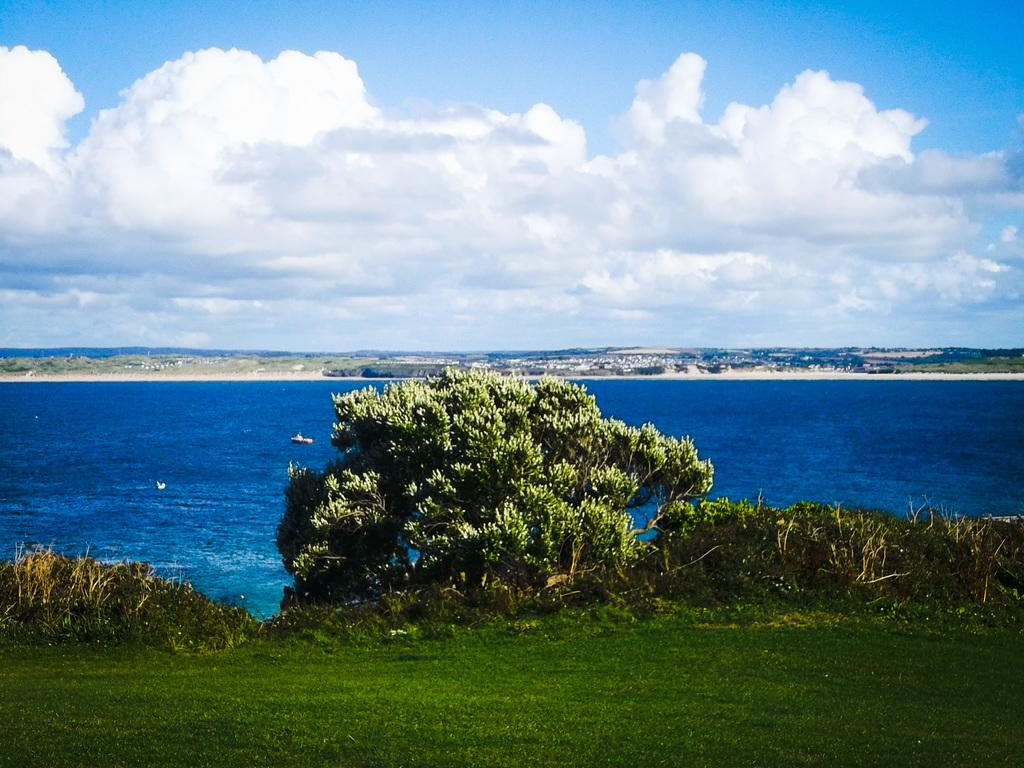What type of vegetation can be seen in the image? There is a tree, plants, and grass visible in the image. What natural element is present in the image? Water is visible in the image. What can be seen in the background of the image? The sky is visible in the background of the image. What is the condition of the sky in the image? There are clouds in the sky. What type of waste can be seen in the image? There is no waste visible in the image. Are there any people sleeping in the image? There are no people present in the image, let alone sleeping. 